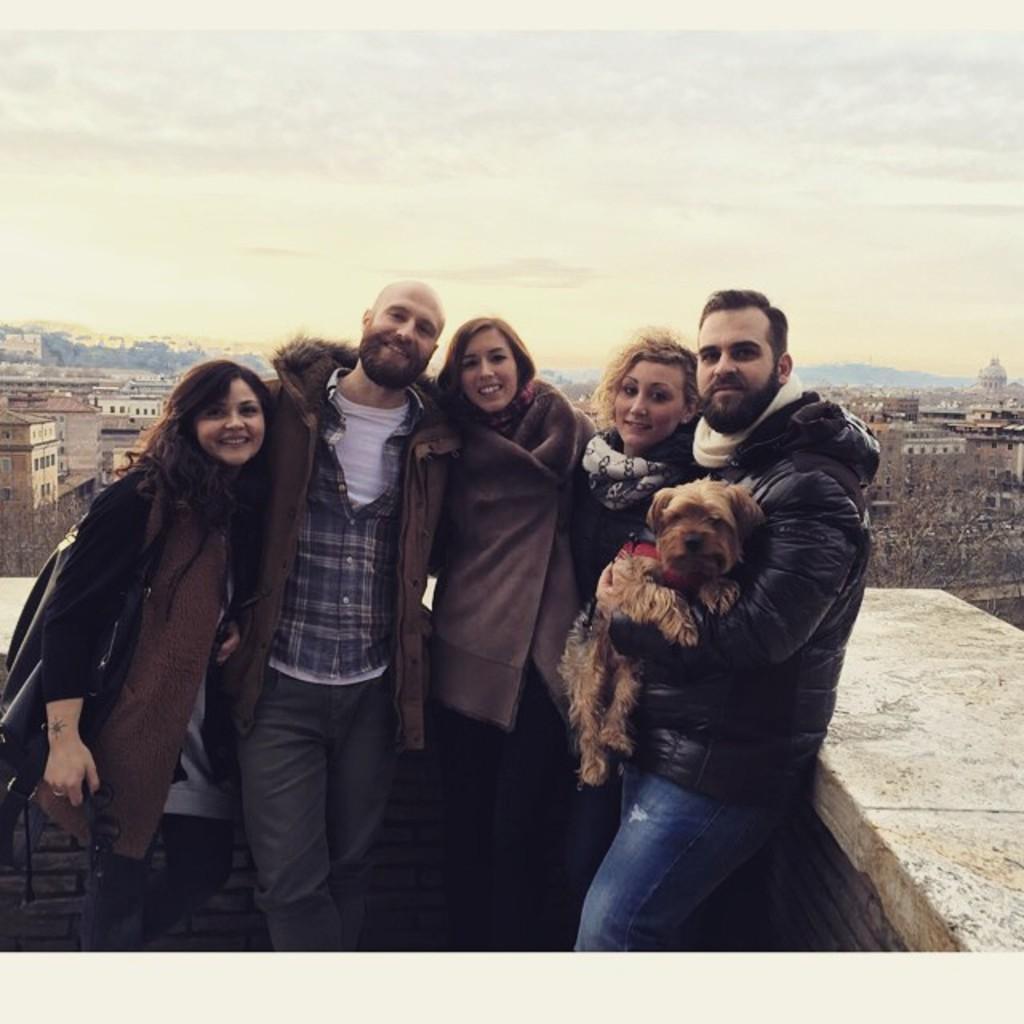How would you summarize this image in a sentence or two? In this picture I can see buildings and trees and few people standing and a man holding a dog in his hand and I can see a cloudy sky. 